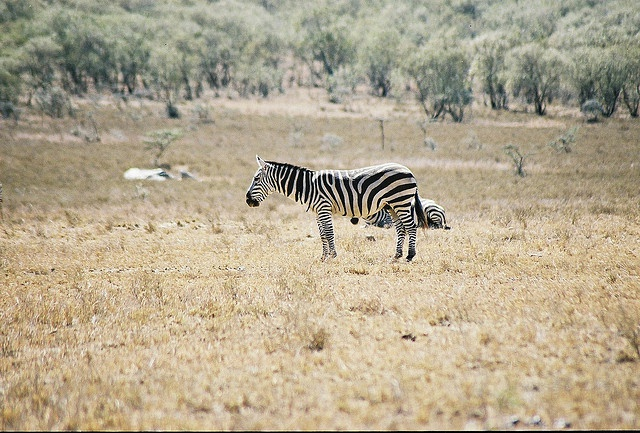Describe the objects in this image and their specific colors. I can see zebra in gray, black, lightgray, and darkgray tones and zebra in gray, black, lightgray, and darkgray tones in this image. 